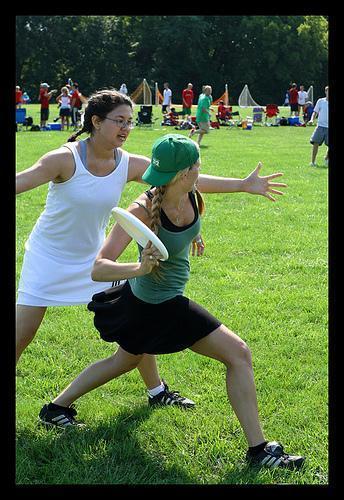How many people have on red shirts?
Give a very brief answer. 7. How many people are there?
Give a very brief answer. 2. 